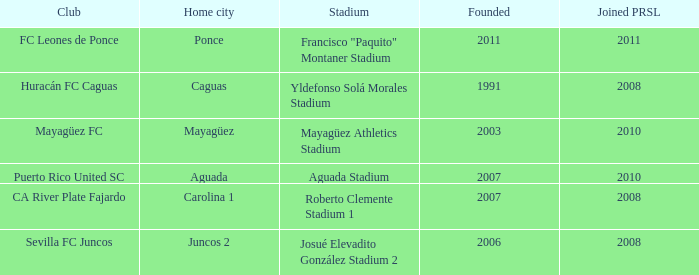What is the club that was founded before 2007, joined prsl in 2008 and the stadium is yldefonso solá morales stadium? Huracán FC Caguas. Could you parse the entire table as a dict? {'header': ['Club', 'Home city', 'Stadium', 'Founded', 'Joined PRSL'], 'rows': [['FC Leones de Ponce', 'Ponce', 'Francisco "Paquito" Montaner Stadium', '2011', '2011'], ['Huracán FC Caguas', 'Caguas', 'Yldefonso Solá Morales Stadium', '1991', '2008'], ['Mayagüez FC', 'Mayagüez', 'Mayagüez Athletics Stadium', '2003', '2010'], ['Puerto Rico United SC', 'Aguada', 'Aguada Stadium', '2007', '2010'], ['CA River Plate Fajardo', 'Carolina 1', 'Roberto Clemente Stadium 1', '2007', '2008'], ['Sevilla FC Juncos', 'Juncos 2', 'Josué Elevadito González Stadium 2', '2006', '2008']]} 